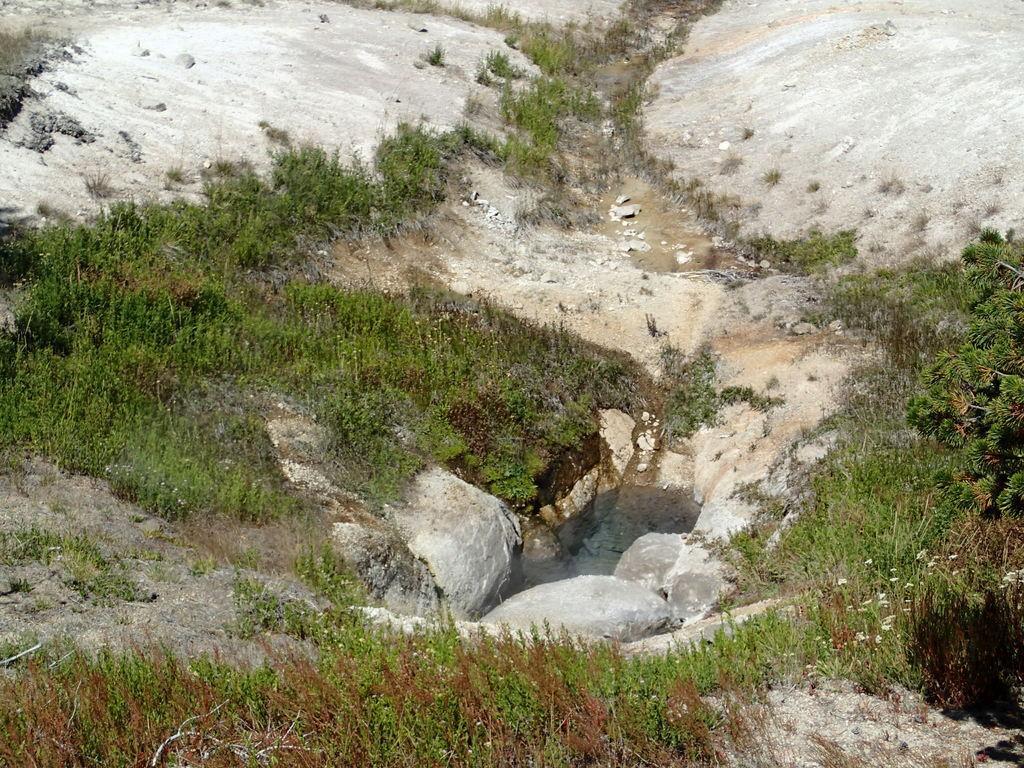In one or two sentences, can you explain what this image depicts? In this image we can see water. Also there are rocks. And there are plants. 